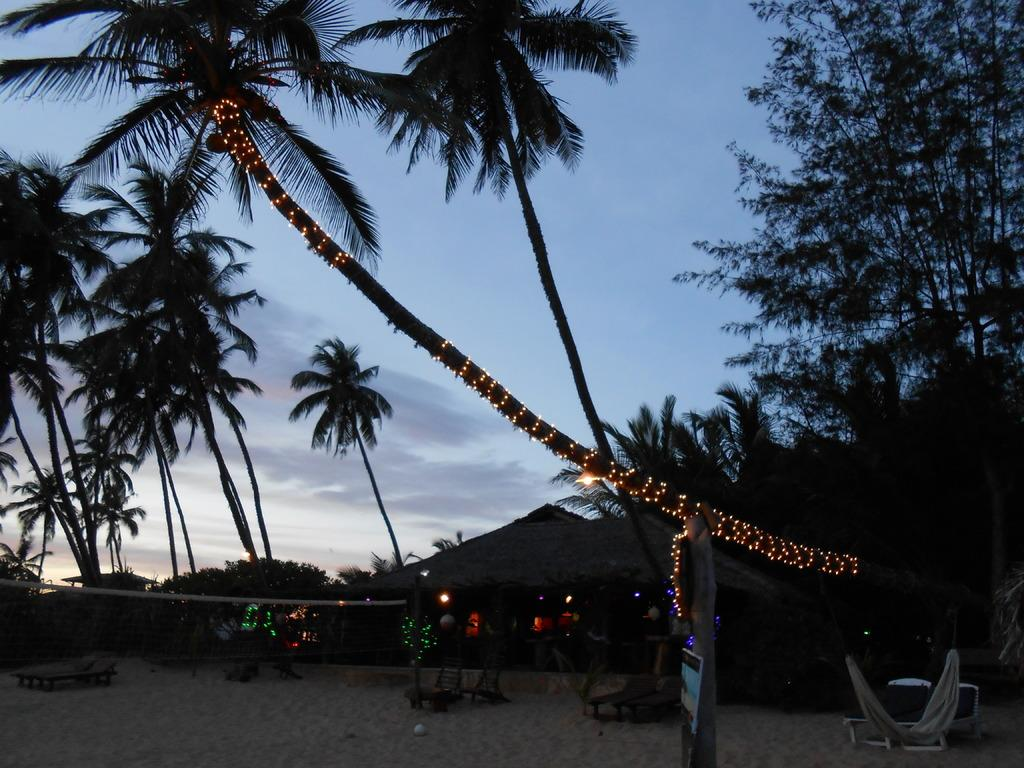What type of vegetation can be seen in the image? There are trees and plants in the image. What type of structure is visible in the image? There is a house in the image. What is visible in the sky in the image? Clouds are present in the sky in the image. How would you describe the lighting in the image? The image appears to be slightly dark. What month is depicted in the image? There is no specific month depicted in the image, as it only shows trees, a house, plants, the sky, clouds, and a slightly dark lighting. Can you see the brain of one of the trees in the image? There is no brain visible in the image, as it only features trees, a house, plants, the sky, clouds, and a slightly dark lighting. 